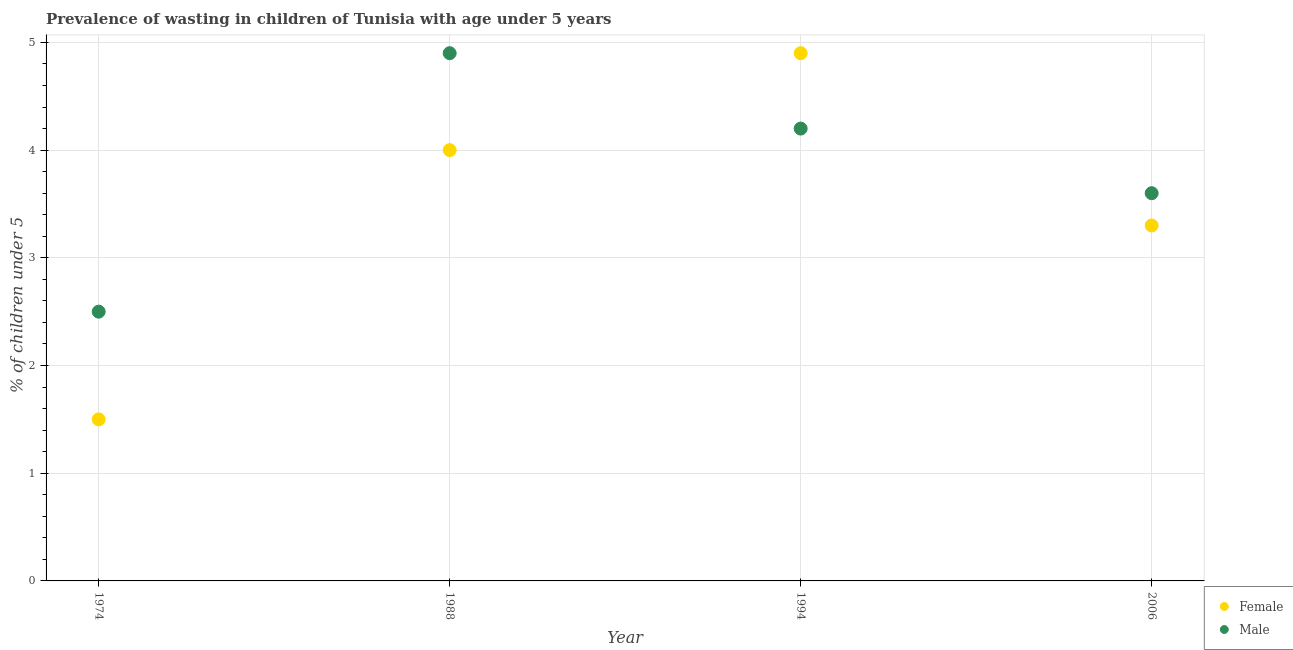How many different coloured dotlines are there?
Give a very brief answer. 2. Across all years, what is the maximum percentage of undernourished female children?
Offer a terse response. 4.9. In which year was the percentage of undernourished male children minimum?
Your answer should be very brief. 1974. What is the total percentage of undernourished male children in the graph?
Your answer should be very brief. 15.2. What is the difference between the percentage of undernourished male children in 1974 and that in 1988?
Keep it short and to the point. -2.4. What is the difference between the percentage of undernourished female children in 1974 and the percentage of undernourished male children in 1994?
Provide a succinct answer. -2.7. What is the average percentage of undernourished male children per year?
Offer a very short reply. 3.8. In the year 1994, what is the difference between the percentage of undernourished female children and percentage of undernourished male children?
Your answer should be very brief. 0.7. What is the ratio of the percentage of undernourished female children in 1994 to that in 2006?
Your answer should be compact. 1.48. What is the difference between the highest and the second highest percentage of undernourished female children?
Your answer should be very brief. 0.9. What is the difference between the highest and the lowest percentage of undernourished male children?
Keep it short and to the point. 2.4. In how many years, is the percentage of undernourished female children greater than the average percentage of undernourished female children taken over all years?
Offer a terse response. 2. Is the sum of the percentage of undernourished female children in 1974 and 1988 greater than the maximum percentage of undernourished male children across all years?
Ensure brevity in your answer.  Yes. Does the percentage of undernourished female children monotonically increase over the years?
Offer a terse response. No. Is the percentage of undernourished male children strictly less than the percentage of undernourished female children over the years?
Provide a succinct answer. No. Does the graph contain any zero values?
Your answer should be compact. No. Does the graph contain grids?
Offer a very short reply. Yes. Where does the legend appear in the graph?
Ensure brevity in your answer.  Bottom right. How are the legend labels stacked?
Make the answer very short. Vertical. What is the title of the graph?
Ensure brevity in your answer.  Prevalence of wasting in children of Tunisia with age under 5 years. What is the label or title of the X-axis?
Offer a terse response. Year. What is the label or title of the Y-axis?
Your answer should be compact.  % of children under 5. What is the  % of children under 5 of Female in 1974?
Your response must be concise. 1.5. What is the  % of children under 5 of Male in 1988?
Your response must be concise. 4.9. What is the  % of children under 5 of Female in 1994?
Ensure brevity in your answer.  4.9. What is the  % of children under 5 of Male in 1994?
Your answer should be very brief. 4.2. What is the  % of children under 5 of Female in 2006?
Make the answer very short. 3.3. What is the  % of children under 5 of Male in 2006?
Offer a terse response. 3.6. Across all years, what is the maximum  % of children under 5 in Female?
Your response must be concise. 4.9. Across all years, what is the maximum  % of children under 5 of Male?
Make the answer very short. 4.9. What is the total  % of children under 5 in Female in the graph?
Give a very brief answer. 13.7. What is the difference between the  % of children under 5 of Male in 1974 and that in 1988?
Provide a succinct answer. -2.4. What is the difference between the  % of children under 5 in Female in 1974 and that in 1994?
Offer a terse response. -3.4. What is the difference between the  % of children under 5 in Male in 1974 and that in 2006?
Your answer should be very brief. -1.1. What is the difference between the  % of children under 5 of Male in 1988 and that in 1994?
Your response must be concise. 0.7. What is the difference between the  % of children under 5 in Female in 1988 and that in 2006?
Provide a short and direct response. 0.7. What is the difference between the  % of children under 5 of Male in 1988 and that in 2006?
Offer a terse response. 1.3. What is the difference between the  % of children under 5 in Female in 1994 and that in 2006?
Offer a terse response. 1.6. What is the difference between the  % of children under 5 in Female in 1988 and the  % of children under 5 in Male in 2006?
Offer a very short reply. 0.4. What is the difference between the  % of children under 5 of Female in 1994 and the  % of children under 5 of Male in 2006?
Your answer should be compact. 1.3. What is the average  % of children under 5 in Female per year?
Your response must be concise. 3.42. What is the ratio of the  % of children under 5 of Male in 1974 to that in 1988?
Ensure brevity in your answer.  0.51. What is the ratio of the  % of children under 5 in Female in 1974 to that in 1994?
Offer a very short reply. 0.31. What is the ratio of the  % of children under 5 in Male in 1974 to that in 1994?
Your answer should be compact. 0.6. What is the ratio of the  % of children under 5 of Female in 1974 to that in 2006?
Give a very brief answer. 0.45. What is the ratio of the  % of children under 5 of Male in 1974 to that in 2006?
Make the answer very short. 0.69. What is the ratio of the  % of children under 5 of Female in 1988 to that in 1994?
Your response must be concise. 0.82. What is the ratio of the  % of children under 5 in Female in 1988 to that in 2006?
Ensure brevity in your answer.  1.21. What is the ratio of the  % of children under 5 in Male in 1988 to that in 2006?
Offer a terse response. 1.36. What is the ratio of the  % of children under 5 in Female in 1994 to that in 2006?
Your answer should be very brief. 1.48. What is the difference between the highest and the second highest  % of children under 5 of Female?
Provide a short and direct response. 0.9. What is the difference between the highest and the second highest  % of children under 5 of Male?
Keep it short and to the point. 0.7. What is the difference between the highest and the lowest  % of children under 5 of Female?
Give a very brief answer. 3.4. What is the difference between the highest and the lowest  % of children under 5 in Male?
Make the answer very short. 2.4. 